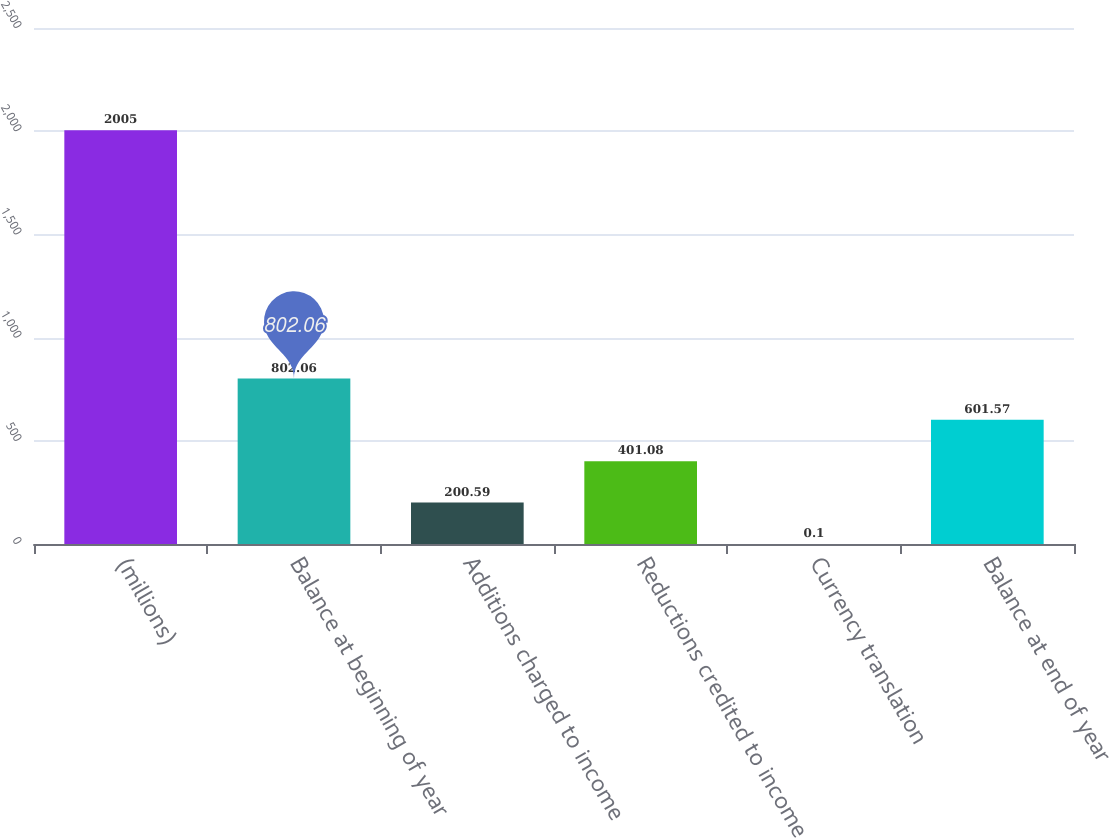<chart> <loc_0><loc_0><loc_500><loc_500><bar_chart><fcel>(millions)<fcel>Balance at beginning of year<fcel>Additions charged to income<fcel>Reductions credited to income<fcel>Currency translation<fcel>Balance at end of year<nl><fcel>2005<fcel>802.06<fcel>200.59<fcel>401.08<fcel>0.1<fcel>601.57<nl></chart> 